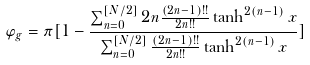<formula> <loc_0><loc_0><loc_500><loc_500>\varphi _ { g } = \pi [ 1 - \frac { \sum _ { n = 0 } ^ { [ N / 2 ] } 2 n \frac { ( 2 n - 1 ) ! ! } { 2 n ! ! } \tanh ^ { 2 ( n - 1 ) } x } { \sum _ { n = 0 } ^ { [ N / 2 ] } \frac { ( 2 n - 1 ) ! ! } { 2 n ! ! } \tanh ^ { 2 ( n - 1 ) } x } ]</formula> 